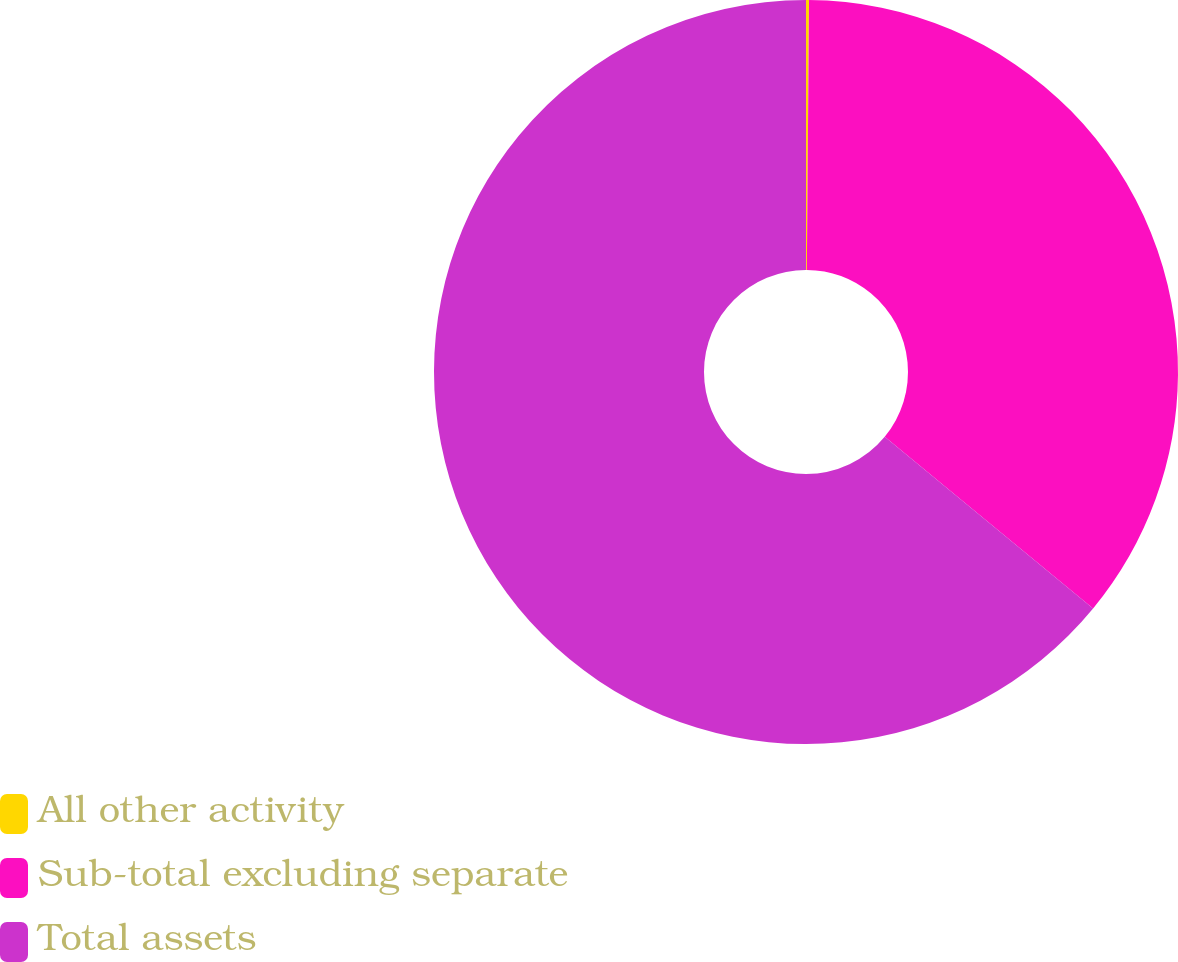Convert chart. <chart><loc_0><loc_0><loc_500><loc_500><pie_chart><fcel>All other activity<fcel>Sub-total excluding separate<fcel>Total assets<nl><fcel>0.13%<fcel>35.84%<fcel>64.03%<nl></chart> 